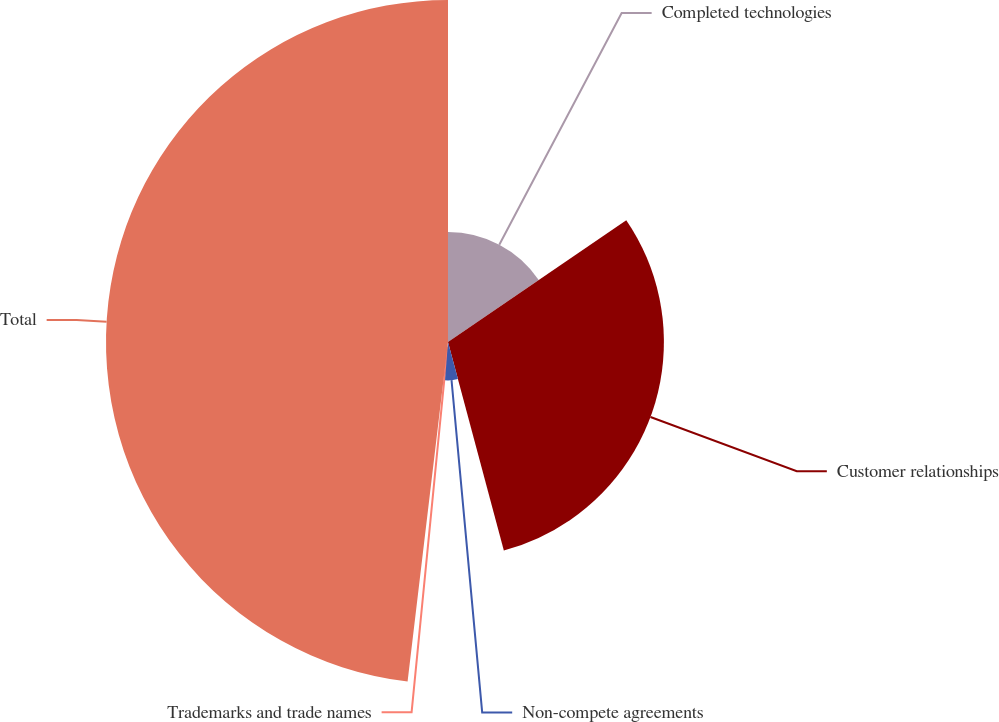Convert chart. <chart><loc_0><loc_0><loc_500><loc_500><pie_chart><fcel>Completed technologies<fcel>Customer relationships<fcel>Non-compete agreements<fcel>Trademarks and trade names<fcel>Total<nl><fcel>15.46%<fcel>30.38%<fcel>5.4%<fcel>0.65%<fcel>48.12%<nl></chart> 